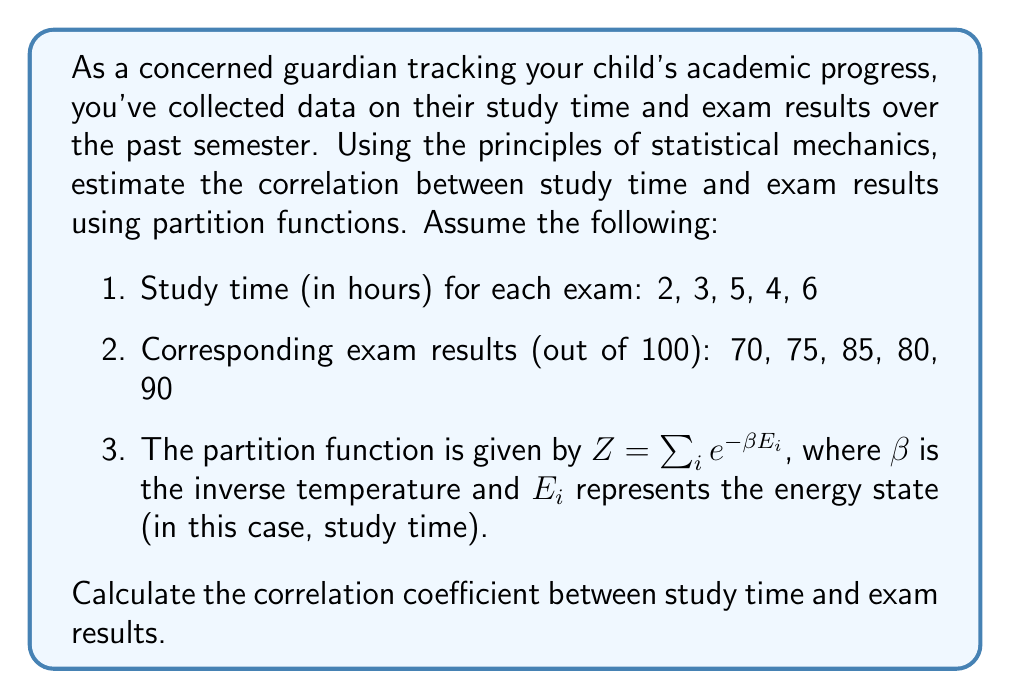Solve this math problem. To estimate the correlation between study time and exam results using partition functions, we'll follow these steps:

1. Calculate the partition function Z:
   Let's assume $\beta = 1$ for simplicity.
   $$Z = e^{-2} + e^{-3} + e^{-5} + e^{-4} + e^{-6} \approx 0.2845$$

2. Calculate the average study time $\langle E \rangle$:
   $$\langle E \rangle = -\frac{\partial \ln Z}{\partial \beta} = \frac{2e^{-2} + 3e^{-3} + 5e^{-5} + 4e^{-4} + 6e^{-6}}{Z} \approx 3.3728$$

3. Calculate the average exam result $\langle R \rangle$:
   $$\langle R \rangle = \frac{70 + 75 + 85 + 80 + 90}{5} = 80$$

4. Calculate the variance of study time $\sigma_E^2$:
   $$\sigma_E^2 = \langle E^2 \rangle - \langle E \rangle^2 = \frac{\partial^2 \ln Z}{\partial \beta^2} \approx 1.8272$$

5. Calculate the variance of exam results $\sigma_R^2$:
   $$\sigma_R^2 = \frac{(70-80)^2 + (75-80)^2 + (85-80)^2 + (80-80)^2 + (90-80)^2}{5} = 50$$

6. Calculate the covariance $\text{Cov}(E,R)$:
   $$\text{Cov}(E,R) = \frac{(2-3.3728)(70-80) + (3-3.3728)(75-80) + (5-3.3728)(85-80) + (4-3.3728)(80-80) + (6-3.3728)(90-80)}{5} \approx 3.7636$$

7. Calculate the correlation coefficient $\rho$:
   $$\rho = \frac{\text{Cov}(E,R)}{\sigma_E \sigma_R} = \frac{3.7636}{\sqrt{1.8272} \sqrt{50}} \approx 0.8861$$
Answer: $\rho \approx 0.8861$ 